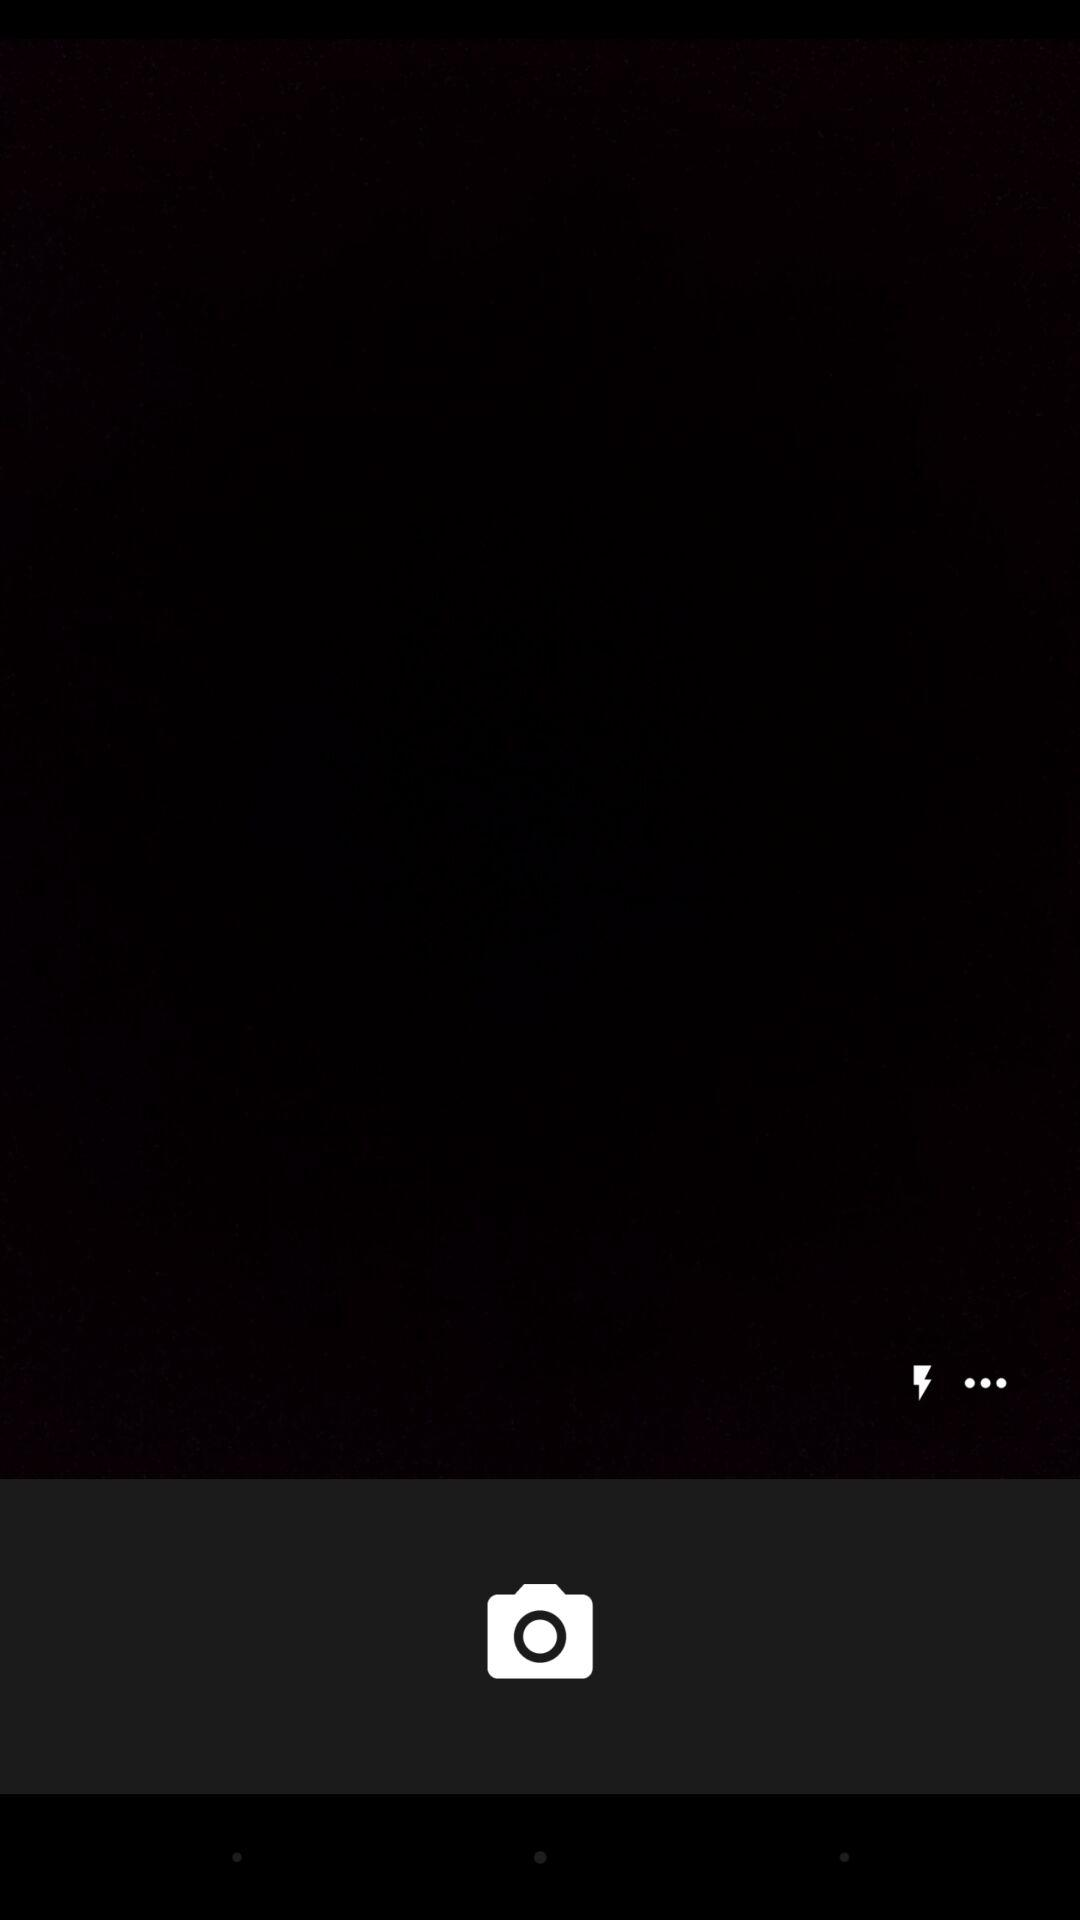How many more white dots are there than lightning bolts?
Answer the question using a single word or phrase. 2 